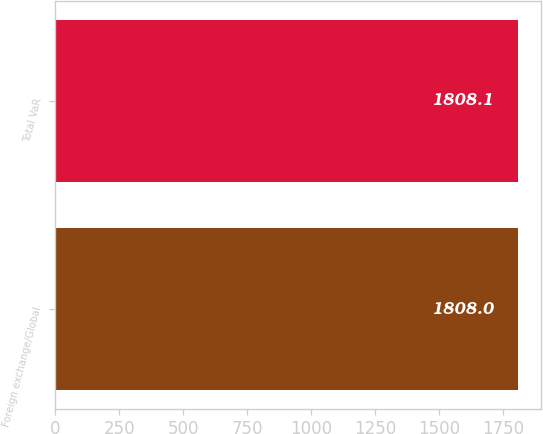<chart> <loc_0><loc_0><loc_500><loc_500><bar_chart><fcel>Foreign exchange/Global<fcel>Total VaR<nl><fcel>1808<fcel>1808.1<nl></chart> 